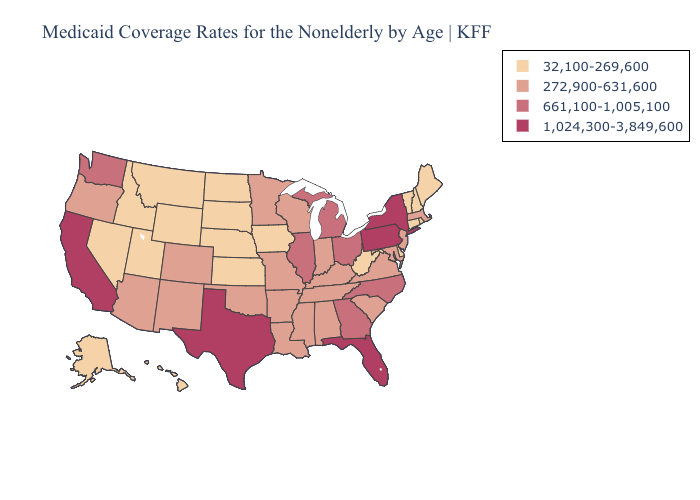Is the legend a continuous bar?
Concise answer only. No. What is the value of Maryland?
Quick response, please. 272,900-631,600. Does Oklahoma have the lowest value in the USA?
Answer briefly. No. Name the states that have a value in the range 1,024,300-3,849,600?
Write a very short answer. California, Florida, New York, Pennsylvania, Texas. What is the lowest value in the MidWest?
Be succinct. 32,100-269,600. What is the value of New Hampshire?
Write a very short answer. 32,100-269,600. Does the map have missing data?
Answer briefly. No. Does California have the highest value in the West?
Keep it brief. Yes. Name the states that have a value in the range 32,100-269,600?
Concise answer only. Alaska, Connecticut, Delaware, Hawaii, Idaho, Iowa, Kansas, Maine, Montana, Nebraska, Nevada, New Hampshire, North Dakota, Rhode Island, South Dakota, Utah, Vermont, West Virginia, Wyoming. Name the states that have a value in the range 661,100-1,005,100?
Keep it brief. Georgia, Illinois, Michigan, North Carolina, Ohio, Washington. Name the states that have a value in the range 272,900-631,600?
Give a very brief answer. Alabama, Arizona, Arkansas, Colorado, Indiana, Kentucky, Louisiana, Maryland, Massachusetts, Minnesota, Mississippi, Missouri, New Jersey, New Mexico, Oklahoma, Oregon, South Carolina, Tennessee, Virginia, Wisconsin. Does California have the highest value in the West?
Be succinct. Yes. Is the legend a continuous bar?
Concise answer only. No. What is the lowest value in the West?
Answer briefly. 32,100-269,600. Does New Hampshire have a higher value than Texas?
Quick response, please. No. 